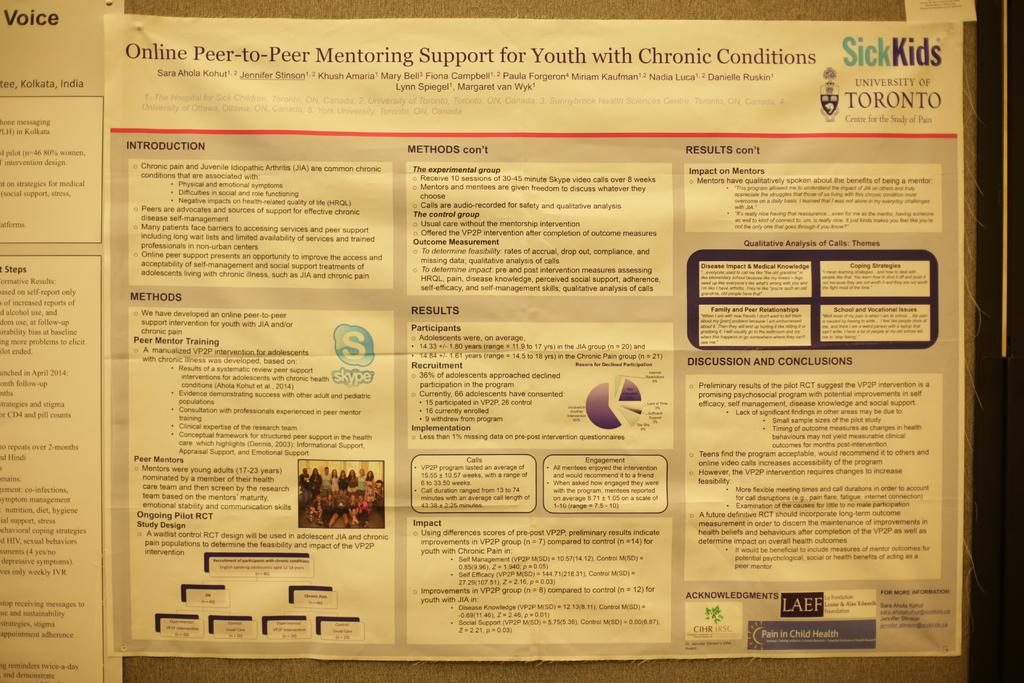<image>
Render a clear and concise summary of the photo. A piece of paperwork about a peer to peer mentoring program for youth with chronic conditions. 